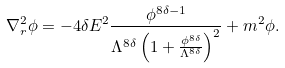<formula> <loc_0><loc_0><loc_500><loc_500>\nabla _ { r } ^ { 2 } \phi = - 4 \delta E ^ { 2 } \frac { \phi ^ { 8 \delta - 1 } } { \Lambda ^ { 8 \delta } \left ( 1 + \frac { \phi ^ { 8 \delta } } { \Lambda ^ { 8 \delta } } \right ) ^ { 2 } } + m ^ { 2 } \phi .</formula> 